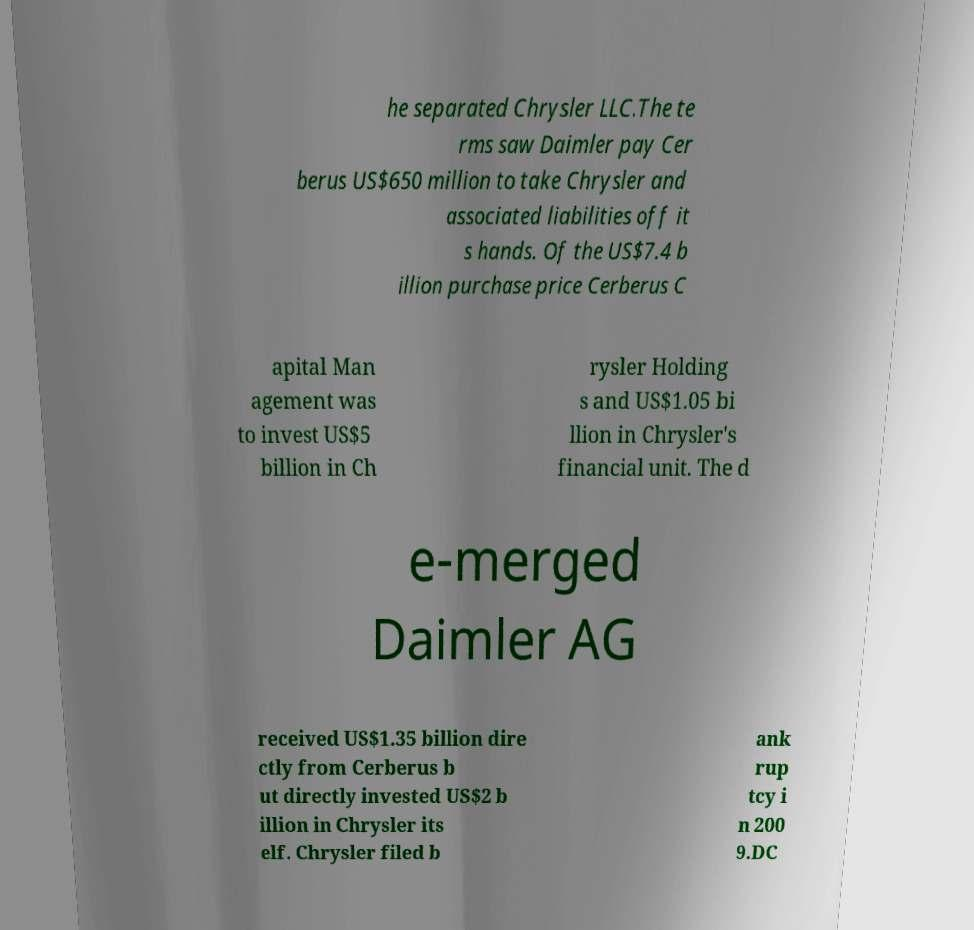Please read and relay the text visible in this image. What does it say? he separated Chrysler LLC.The te rms saw Daimler pay Cer berus US$650 million to take Chrysler and associated liabilities off it s hands. Of the US$7.4 b illion purchase price Cerberus C apital Man agement was to invest US$5 billion in Ch rysler Holding s and US$1.05 bi llion in Chrysler's financial unit. The d e-merged Daimler AG received US$1.35 billion dire ctly from Cerberus b ut directly invested US$2 b illion in Chrysler its elf. Chrysler filed b ank rup tcy i n 200 9.DC 